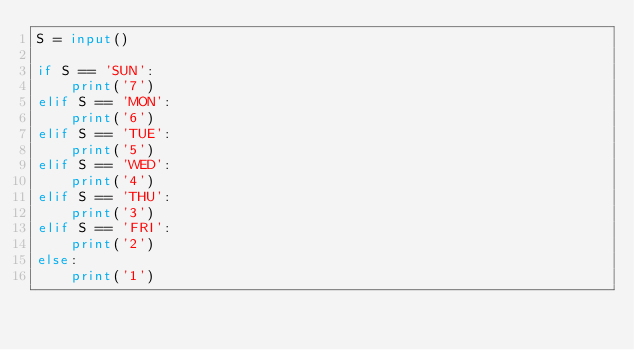Convert code to text. <code><loc_0><loc_0><loc_500><loc_500><_Python_>S = input()

if S == 'SUN':
    print('7')
elif S == 'MON':
    print('6')
elif S == 'TUE':
    print('5')
elif S == 'WED':
    print('4')
elif S == 'THU':
    print('3')
elif S == 'FRI':
    print('2')
else:
    print('1')</code> 